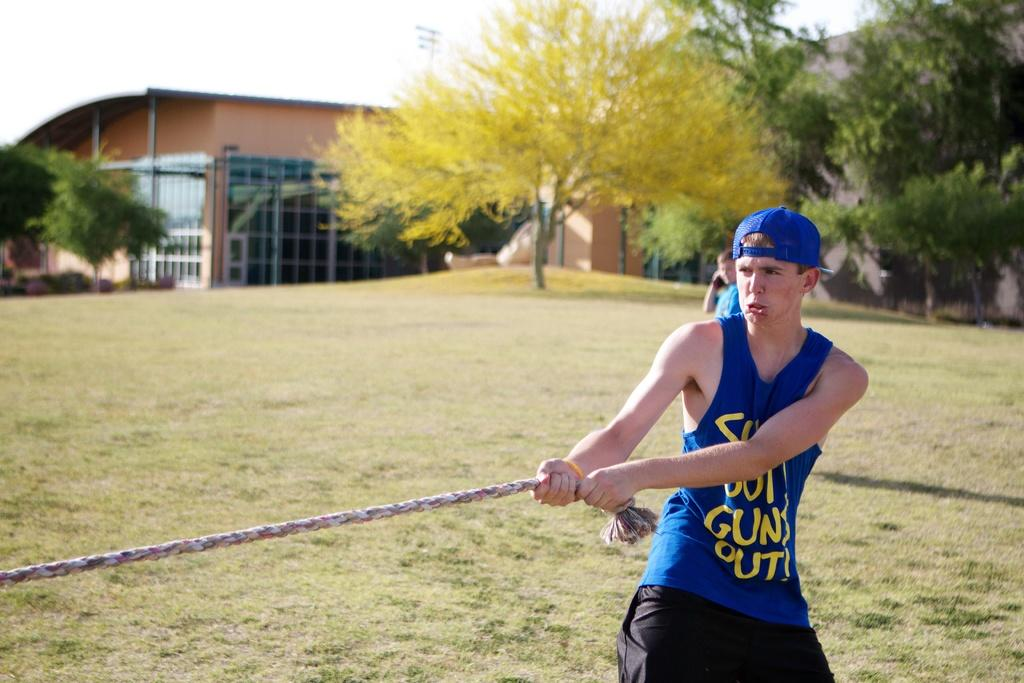<image>
Summarize the visual content of the image. The man in the blue top and hat has the word guns on his top. 